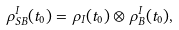Convert formula to latex. <formula><loc_0><loc_0><loc_500><loc_500>\rho ^ { I } _ { S B } ( t _ { 0 } ) = \rho _ { I } ( t _ { 0 } ) \otimes \rho ^ { I } _ { B } ( t _ { 0 } ) ,</formula> 